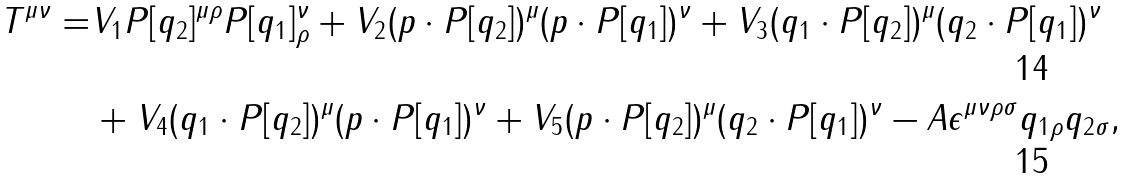Convert formula to latex. <formula><loc_0><loc_0><loc_500><loc_500>T ^ { \mu \nu } = & V _ { 1 } P [ q _ { 2 } ] ^ { \mu \rho } P [ q _ { 1 } ] ^ { \nu } _ { \rho } + V _ { 2 } ( p \cdot P [ q _ { 2 } ] ) ^ { \mu } ( p \cdot P [ q _ { 1 } ] ) ^ { \nu } + V _ { 3 } ( q _ { 1 } \cdot P [ q _ { 2 } ] ) ^ { \mu } ( q _ { 2 } \cdot P [ q _ { 1 } ] ) ^ { \nu } \\ & + V _ { 4 } ( q _ { 1 } \cdot P [ q _ { 2 } ] ) ^ { \mu } ( p \cdot P [ q _ { 1 } ] ) ^ { \nu } + V _ { 5 } ( p \cdot P [ q _ { 2 } ] ) ^ { \mu } ( q _ { 2 } \cdot P [ q _ { 1 } ] ) ^ { \nu } - A \epsilon ^ { \mu \nu \rho \sigma } q _ { 1 \rho } q _ { 2 \sigma } ,</formula> 